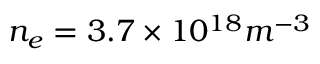Convert formula to latex. <formula><loc_0><loc_0><loc_500><loc_500>n _ { e } = 3 . 7 \times 1 0 ^ { 1 8 } m ^ { - 3 }</formula> 